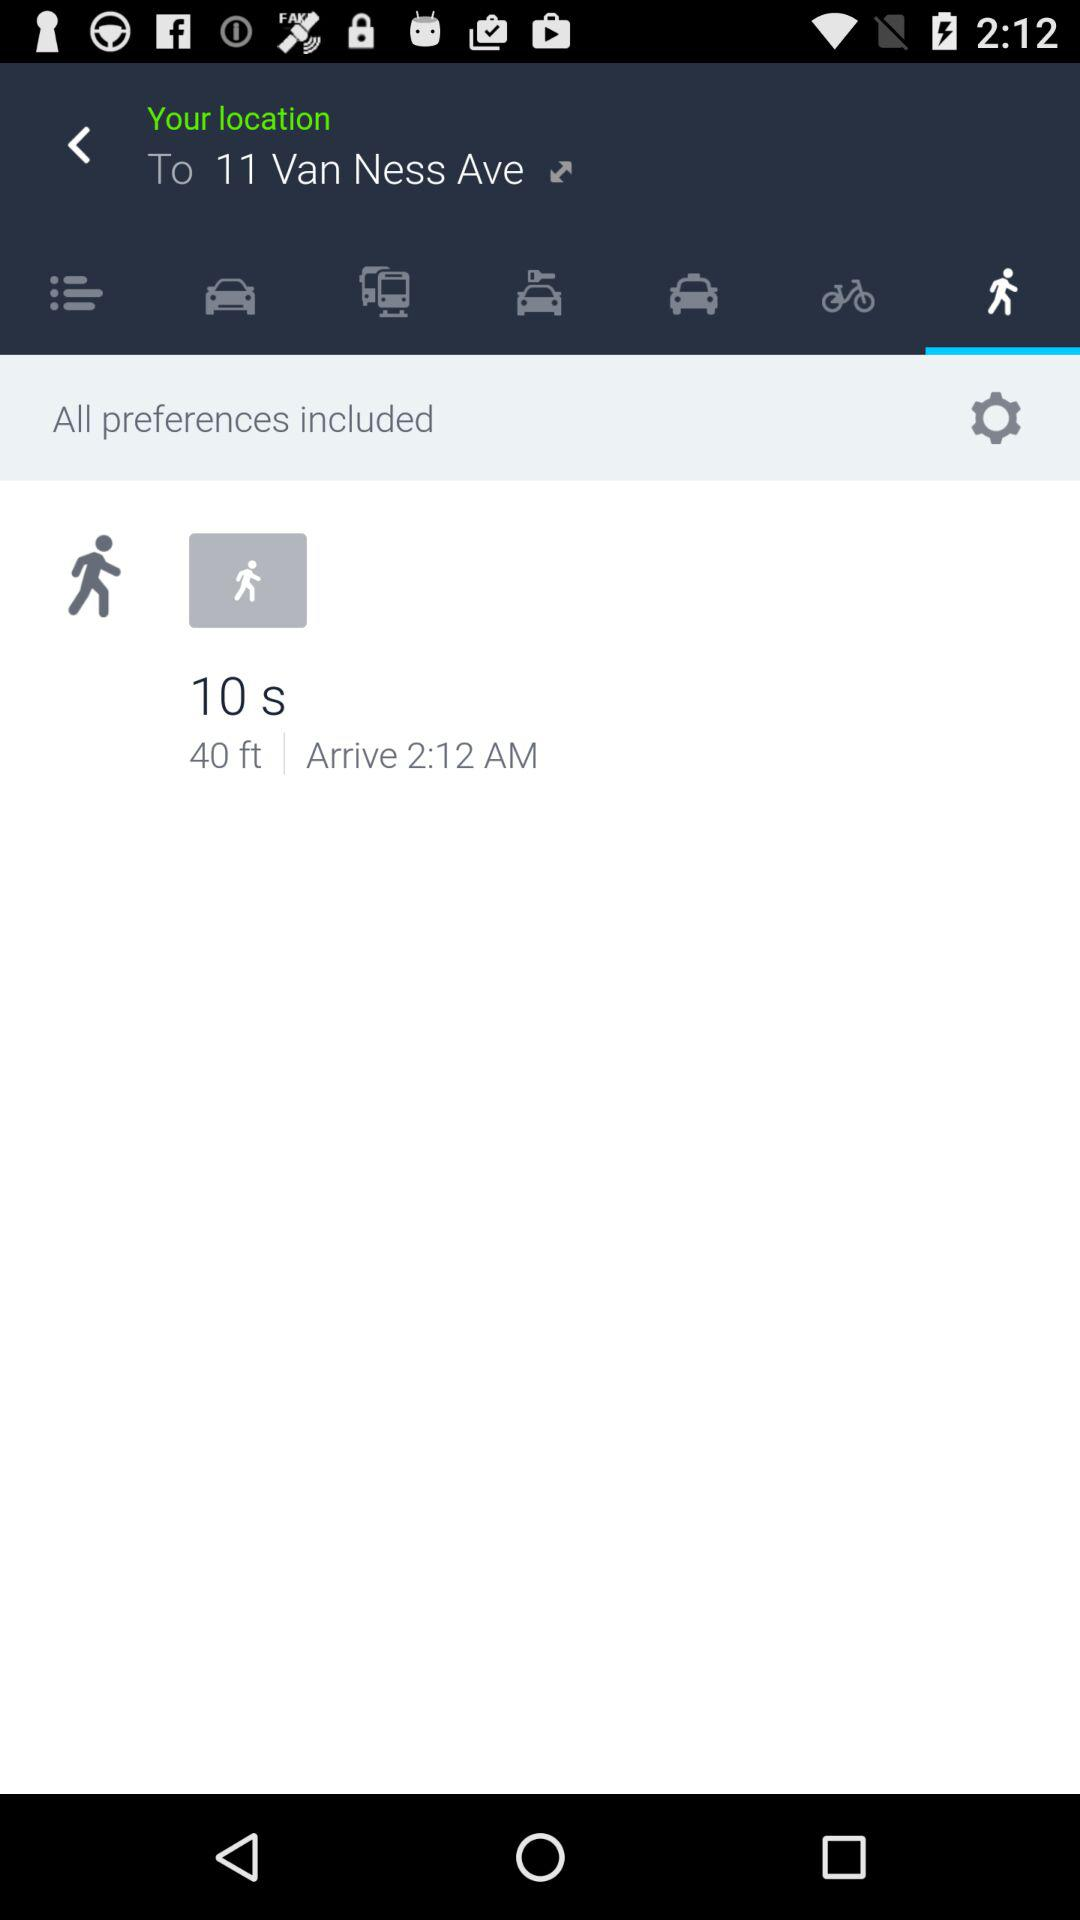How many feet away is my destination?
Answer the question using a single word or phrase. 40 ft 